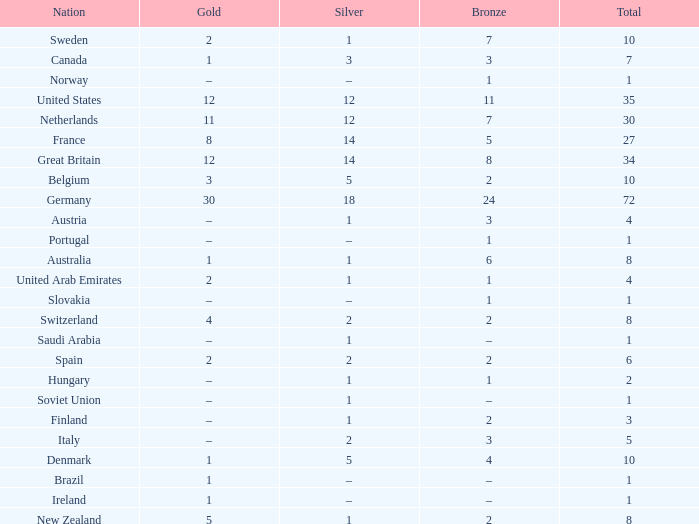What is the total number of Total, when Silver is 1, and when Bronze is 7? 1.0. 